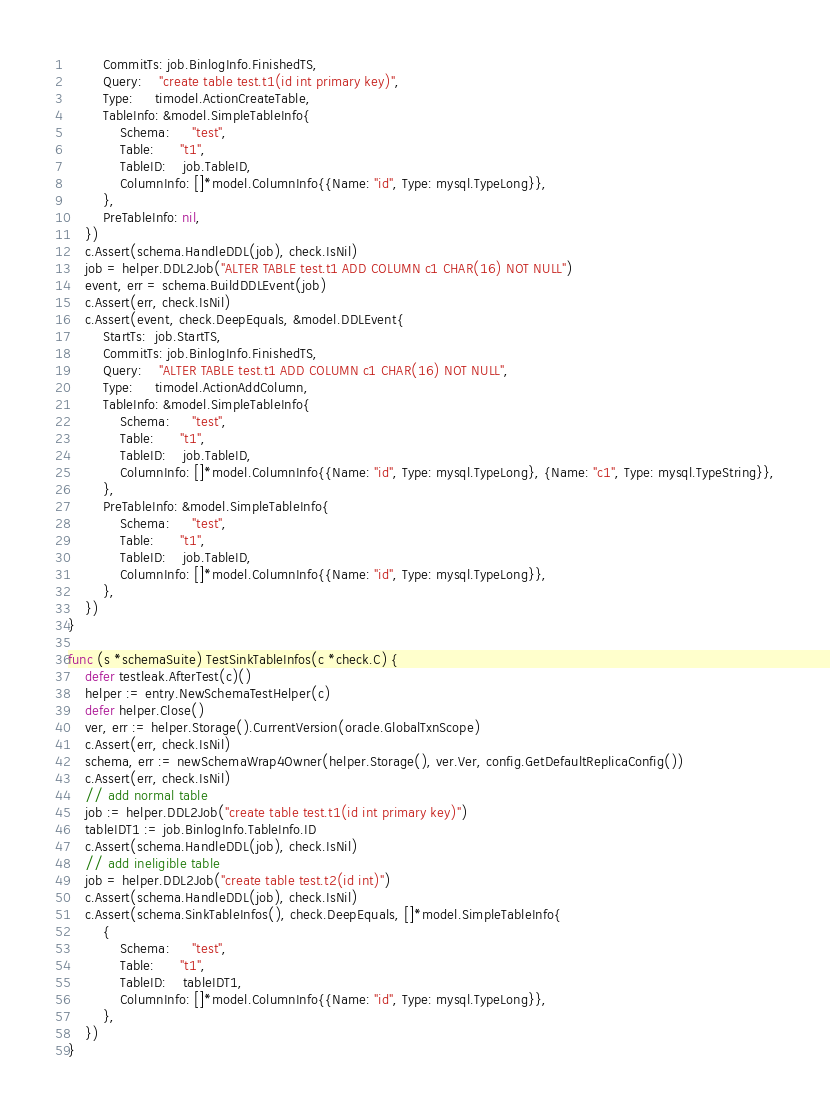Convert code to text. <code><loc_0><loc_0><loc_500><loc_500><_Go_>		CommitTs: job.BinlogInfo.FinishedTS,
		Query:    "create table test.t1(id int primary key)",
		Type:     timodel.ActionCreateTable,
		TableInfo: &model.SimpleTableInfo{
			Schema:     "test",
			Table:      "t1",
			TableID:    job.TableID,
			ColumnInfo: []*model.ColumnInfo{{Name: "id", Type: mysql.TypeLong}},
		},
		PreTableInfo: nil,
	})
	c.Assert(schema.HandleDDL(job), check.IsNil)
	job = helper.DDL2Job("ALTER TABLE test.t1 ADD COLUMN c1 CHAR(16) NOT NULL")
	event, err = schema.BuildDDLEvent(job)
	c.Assert(err, check.IsNil)
	c.Assert(event, check.DeepEquals, &model.DDLEvent{
		StartTs:  job.StartTS,
		CommitTs: job.BinlogInfo.FinishedTS,
		Query:    "ALTER TABLE test.t1 ADD COLUMN c1 CHAR(16) NOT NULL",
		Type:     timodel.ActionAddColumn,
		TableInfo: &model.SimpleTableInfo{
			Schema:     "test",
			Table:      "t1",
			TableID:    job.TableID,
			ColumnInfo: []*model.ColumnInfo{{Name: "id", Type: mysql.TypeLong}, {Name: "c1", Type: mysql.TypeString}},
		},
		PreTableInfo: &model.SimpleTableInfo{
			Schema:     "test",
			Table:      "t1",
			TableID:    job.TableID,
			ColumnInfo: []*model.ColumnInfo{{Name: "id", Type: mysql.TypeLong}},
		},
	})
}

func (s *schemaSuite) TestSinkTableInfos(c *check.C) {
	defer testleak.AfterTest(c)()
	helper := entry.NewSchemaTestHelper(c)
	defer helper.Close()
	ver, err := helper.Storage().CurrentVersion(oracle.GlobalTxnScope)
	c.Assert(err, check.IsNil)
	schema, err := newSchemaWrap4Owner(helper.Storage(), ver.Ver, config.GetDefaultReplicaConfig())
	c.Assert(err, check.IsNil)
	// add normal table
	job := helper.DDL2Job("create table test.t1(id int primary key)")
	tableIDT1 := job.BinlogInfo.TableInfo.ID
	c.Assert(schema.HandleDDL(job), check.IsNil)
	// add ineligible table
	job = helper.DDL2Job("create table test.t2(id int)")
	c.Assert(schema.HandleDDL(job), check.IsNil)
	c.Assert(schema.SinkTableInfos(), check.DeepEquals, []*model.SimpleTableInfo{
		{
			Schema:     "test",
			Table:      "t1",
			TableID:    tableIDT1,
			ColumnInfo: []*model.ColumnInfo{{Name: "id", Type: mysql.TypeLong}},
		},
	})
}
</code> 